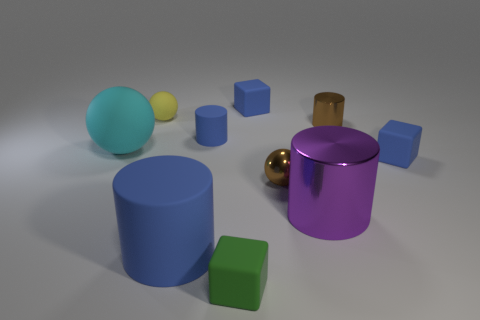Subtract 3 cylinders. How many cylinders are left? 1 Subtract all cyan spheres. How many spheres are left? 2 Subtract all green matte blocks. How many blocks are left? 2 Subtract all brown blocks. Subtract all cyan spheres. How many blocks are left? 3 Subtract all gray balls. How many brown cylinders are left? 1 Subtract all yellow matte cylinders. Subtract all big blue things. How many objects are left? 9 Add 5 small yellow matte objects. How many small yellow matte objects are left? 6 Add 1 gray metallic blocks. How many gray metallic blocks exist? 1 Subtract 1 green cubes. How many objects are left? 9 Subtract all cylinders. How many objects are left? 6 